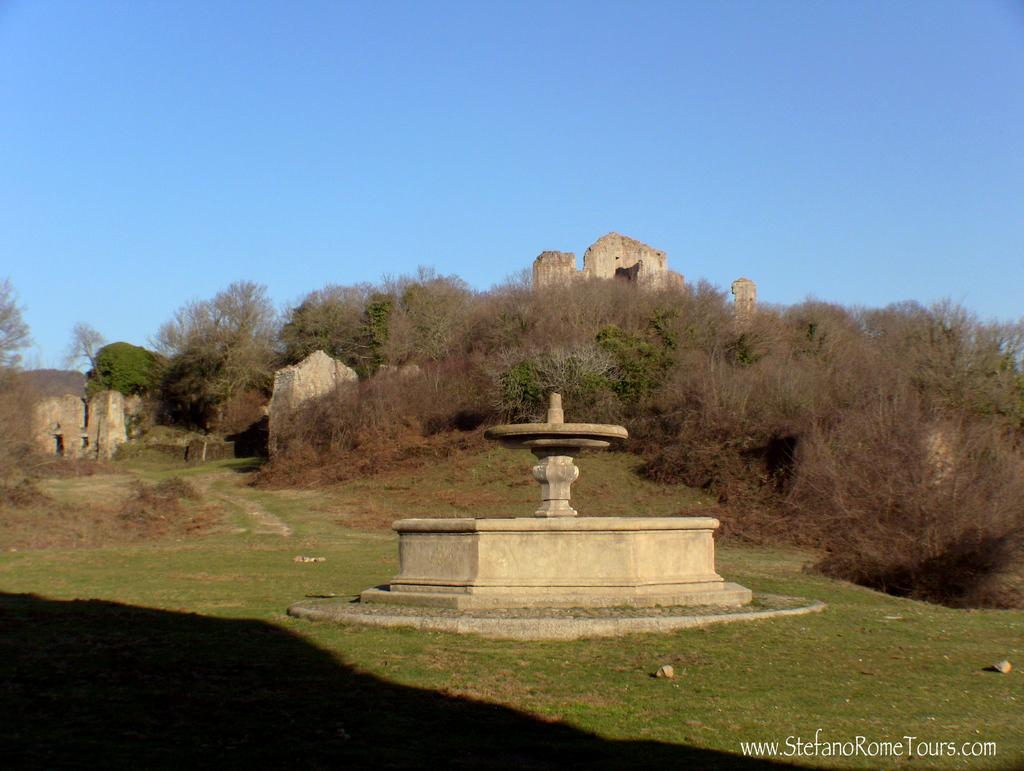What is the main feature in the image? There is a fountain in the image. What can be seen in the background of the image? There are plants and monuments in the background of the image. What is visible in the sky in the image? The sky is visible in the image. What type of haircut is the fountain giving in the image? The fountain is not giving a haircut in the image, as it is a water feature and not a person or animal capable of providing such a service. 